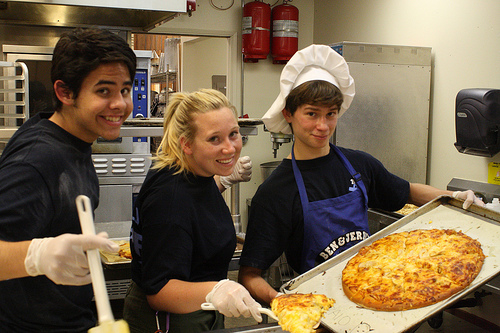What are the people doing in this picture? The individuals are involved in a cooking activity, with one person holding a large, freshly baked pizza, which suggests they might be in a pizza-making class or a restaurant kitchen. 